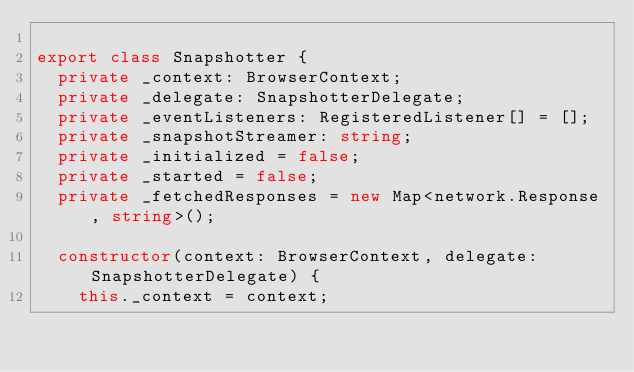<code> <loc_0><loc_0><loc_500><loc_500><_TypeScript_>
export class Snapshotter {
  private _context: BrowserContext;
  private _delegate: SnapshotterDelegate;
  private _eventListeners: RegisteredListener[] = [];
  private _snapshotStreamer: string;
  private _initialized = false;
  private _started = false;
  private _fetchedResponses = new Map<network.Response, string>();

  constructor(context: BrowserContext, delegate: SnapshotterDelegate) {
    this._context = context;</code> 